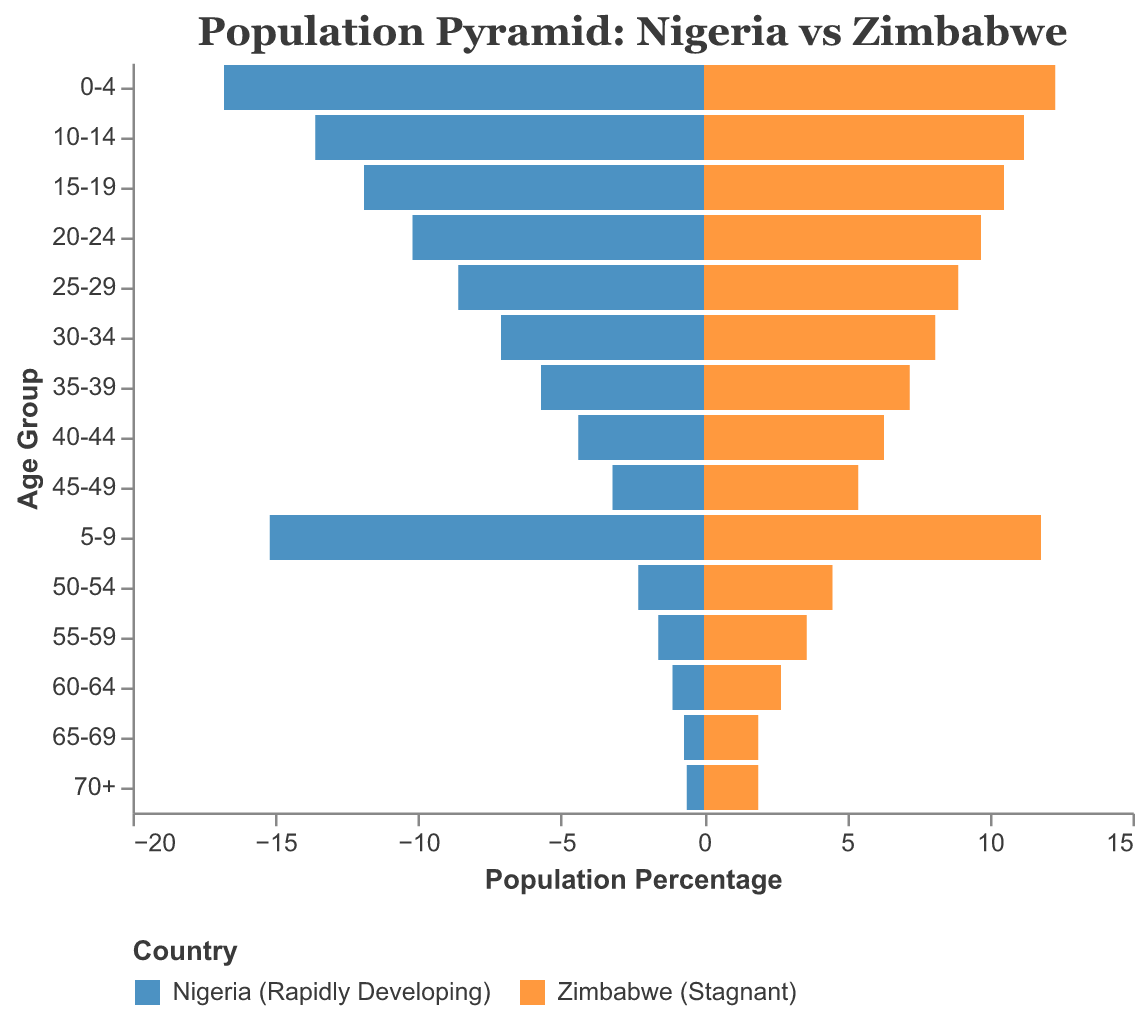What is the age group with the highest population percentage in Nigeria (Rapidly Developing)? The age group with the highest population percentage in Nigeria is identified by the tallest bar in the population pyramid for Nigeria. The age groups are listed on the y-axis, and the population percentages are shown on the x-axis with Nigeria represented by blue bars. The 0-4 age group has the highest population percentage at 16.8%.
Answer: 0-4 Which age group has a relatively similar population percentage for both Nigeria (Rapidly Developing) and Zimbabwe (Stagnant)? By comparing the bars representing Nigeria and Zimbabwe across different age groups, we note that the 25-29 age group has relatively similar population percentages, with Nigeria at 8.6% and Zimbabwe at 8.9%.
Answer: 25-29 How does the population percentage of the 60-64 age group in Nigeria compare to Zimbabwe? From the figure, we observe that the bar for the 60-64 age group is longer on the Zimbabwe side compared to Nigeria. Specifically, Zimbabwe has 2.7%, while Nigeria has 1.1%, meaning Zimbabwe's population percentage is higher for this age group.
Answer: Zimbabwe's is higher What is the total population percentage of individuals aged 45 and above in Zimbabwe? Sum the population percentages of age groups 45-49, 50-54, 55-59, 60-64, 65-69, and 70+ for Zimbabwe. These values are 5.4%, 4.5%, 3.6%, 2.7%, 1.9%, and 1.9%. The total is 5.4 + 4.5 + 3.6 + 2.7 + 1.9 + 1.9 = 20.0%.
Answer: 20.0% Which country has a larger proportion of young individuals (under 15 years old)? By looking at the combined bars for the age groups 0-4, 5-9, and 10-14, we sum the values for both countries. For Nigeria: 16.8 + 15.2 + 13.6 = 45.6%; for Zimbabwe: 12.3 + 11.8 + 11.2 = 35.3%. Thus, Nigeria has a larger proportion of young individuals.
Answer: Nigeria Is the elderly population percentage (70+) higher in Nigeria or Zimbabwe? By checking the population percentage for the 70+ age group on the figure, Zimbabwe has a 1.9% population percentage, while Nigeria has 0.6%. Zimbabwe has a higher elderly population percentage.
Answer: Zimbabwe What is the average population percentage for age groups 30-34 and 35-39 in Nigeria? Compute the average percentage for Nigeria: (7.1 + 5.7) / 2 = 12.8 / 2 = 6.4%.
Answer: 6.4% Which country shows a sharper decline in population percentage as age increases? By observing the steepness of the decline in the bars from younger to older age groups, Nigeria shows a sharper decline compared to Zimbabwe, indicating a higher birth rate and lower life expectancy.
Answer: Nigeria What is the median age group based on population percentage for Zimbabwe? To find the median age group for Zimbabwe, list down the population percentages and find the middle value. For Zimbabwe, the order is approximately: 0-4 (12.3%), 5-9 (11.8%), 10-14 (11.2%), 15-19 (10.5%), 20-24 (9.7%), 25-29 (8.9%), 30-34 (8.1%), 35-39 (7.2%), 40-44 (6.3%), 45-49 (5.4%), 50-54 (4.5%), 55-59 (3.6%), 60-64 (2.7%), 65-69 (1.9%), 70+ (1.9%). The median age group is the 25-29 age group.
Answer: 25-29 